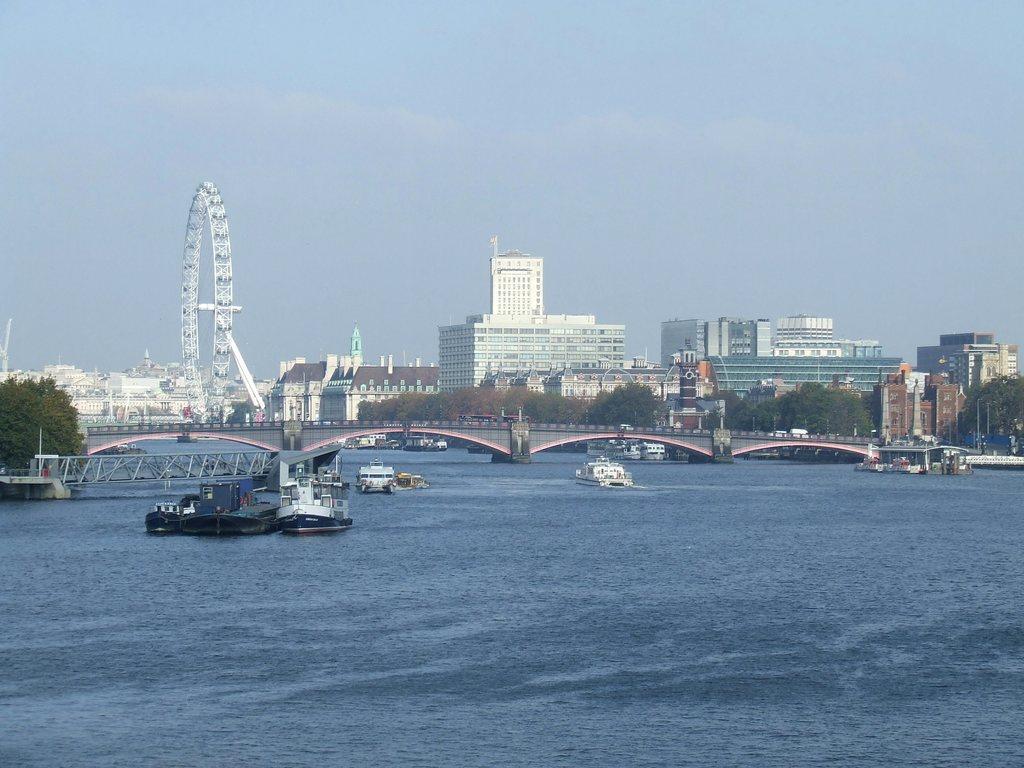In one or two sentences, can you explain what this image depicts? In this image, we can see some boats floating on the water. There is a bridge and some buildings in the middle of the image. In the background of the image, there is a sky. 